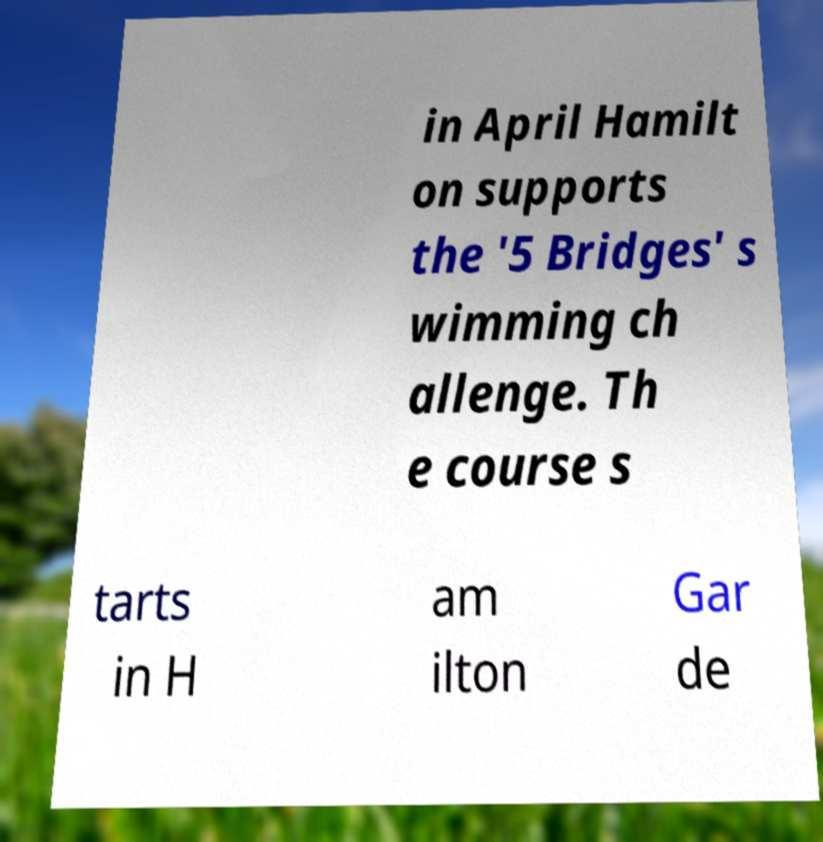For documentation purposes, I need the text within this image transcribed. Could you provide that? in April Hamilt on supports the '5 Bridges' s wimming ch allenge. Th e course s tarts in H am ilton Gar de 